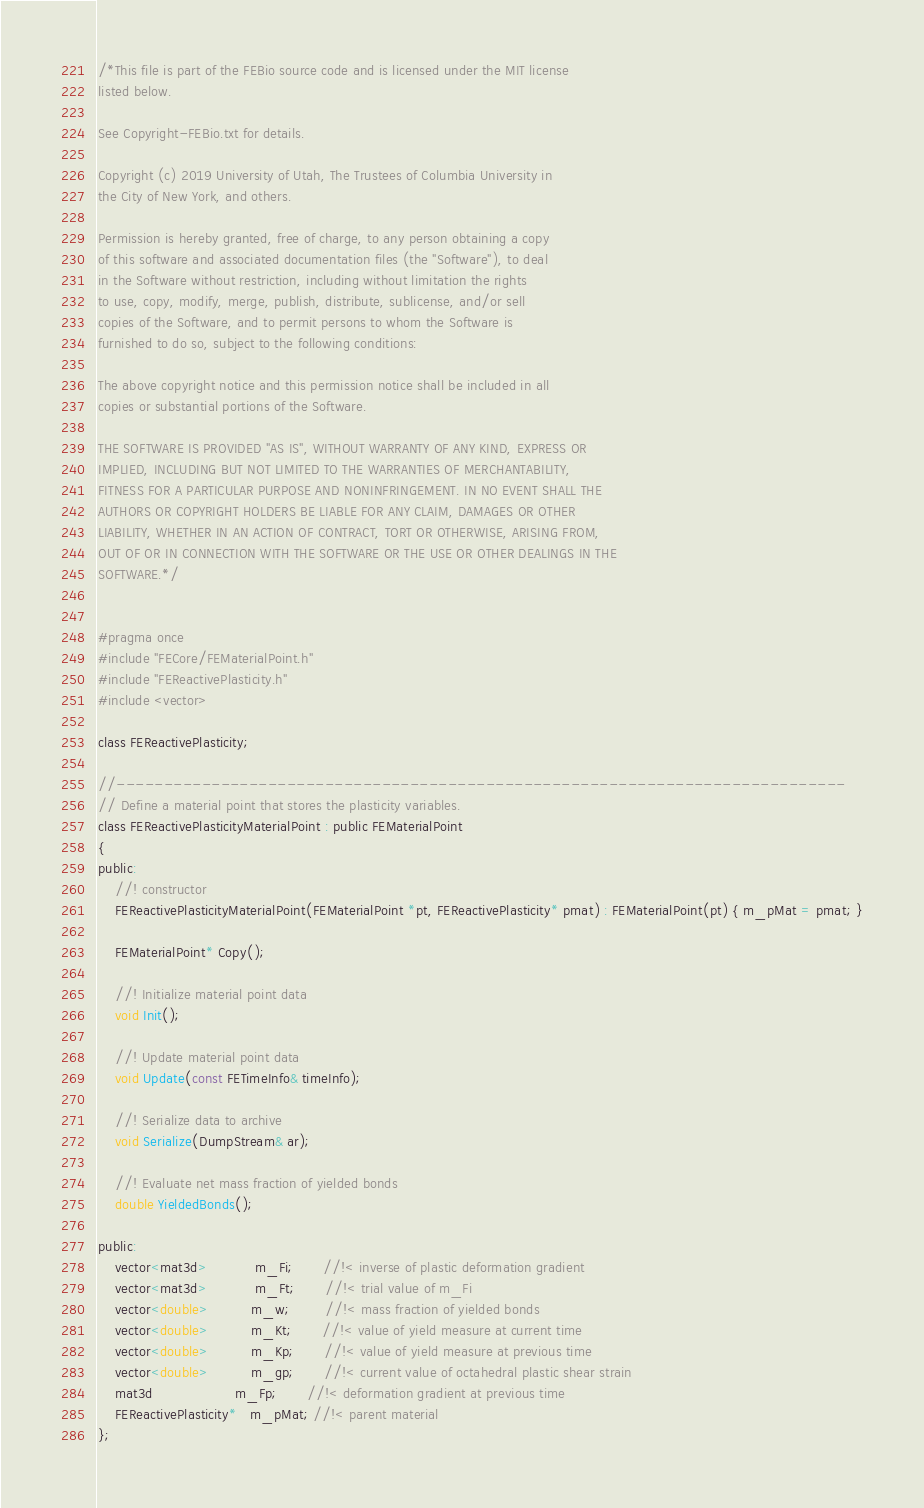Convert code to text. <code><loc_0><loc_0><loc_500><loc_500><_C_>/*This file is part of the FEBio source code and is licensed under the MIT license
listed below.

See Copyright-FEBio.txt for details.

Copyright (c) 2019 University of Utah, The Trustees of Columbia University in 
the City of New York, and others.

Permission is hereby granted, free of charge, to any person obtaining a copy
of this software and associated documentation files (the "Software"), to deal
in the Software without restriction, including without limitation the rights
to use, copy, modify, merge, publish, distribute, sublicense, and/or sell
copies of the Software, and to permit persons to whom the Software is
furnished to do so, subject to the following conditions:

The above copyright notice and this permission notice shall be included in all
copies or substantial portions of the Software.

THE SOFTWARE IS PROVIDED "AS IS", WITHOUT WARRANTY OF ANY KIND, EXPRESS OR
IMPLIED, INCLUDING BUT NOT LIMITED TO THE WARRANTIES OF MERCHANTABILITY,
FITNESS FOR A PARTICULAR PURPOSE AND NONINFRINGEMENT. IN NO EVENT SHALL THE
AUTHORS OR COPYRIGHT HOLDERS BE LIABLE FOR ANY CLAIM, DAMAGES OR OTHER
LIABILITY, WHETHER IN AN ACTION OF CONTRACT, TORT OR OTHERWISE, ARISING FROM,
OUT OF OR IN CONNECTION WITH THE SOFTWARE OR THE USE OR OTHER DEALINGS IN THE
SOFTWARE.*/


#pragma once
#include "FECore/FEMaterialPoint.h"
#include "FEReactivePlasticity.h"
#include <vector>

class FEReactivePlasticity;

//-----------------------------------------------------------------------------
// Define a material point that stores the plasticity variables.
class FEReactivePlasticityMaterialPoint : public FEMaterialPoint
{
public:
    //! constructor
    FEReactivePlasticityMaterialPoint(FEMaterialPoint *pt, FEReactivePlasticity* pmat) : FEMaterialPoint(pt) { m_pMat = pmat; }
    
    FEMaterialPoint* Copy();
    
    //! Initialize material point data
    void Init();

    //! Update material point data
    void Update(const FETimeInfo& timeInfo);
    
    //! Serialize data to archive
    void Serialize(DumpStream& ar);
    
    //! Evaluate net mass fraction of yielded bonds
    double YieldedBonds();
    
public:
    vector<mat3d>           m_Fi;       //!< inverse of plastic deformation gradient
    vector<mat3d>           m_Ft;       //!< trial value of m_Fi
    vector<double>          m_w;        //!< mass fraction of yielded bonds
    vector<double>          m_Kt;       //!< value of yield measure at current time
    vector<double>          m_Kp;       //!< value of yield measure at previous time
    vector<double>          m_gp;       //!< current value of octahedral plastic shear strain
    mat3d                   m_Fp;       //!< deformation gradient at previous time
    FEReactivePlasticity*   m_pMat; //!< parent material
};
</code> 